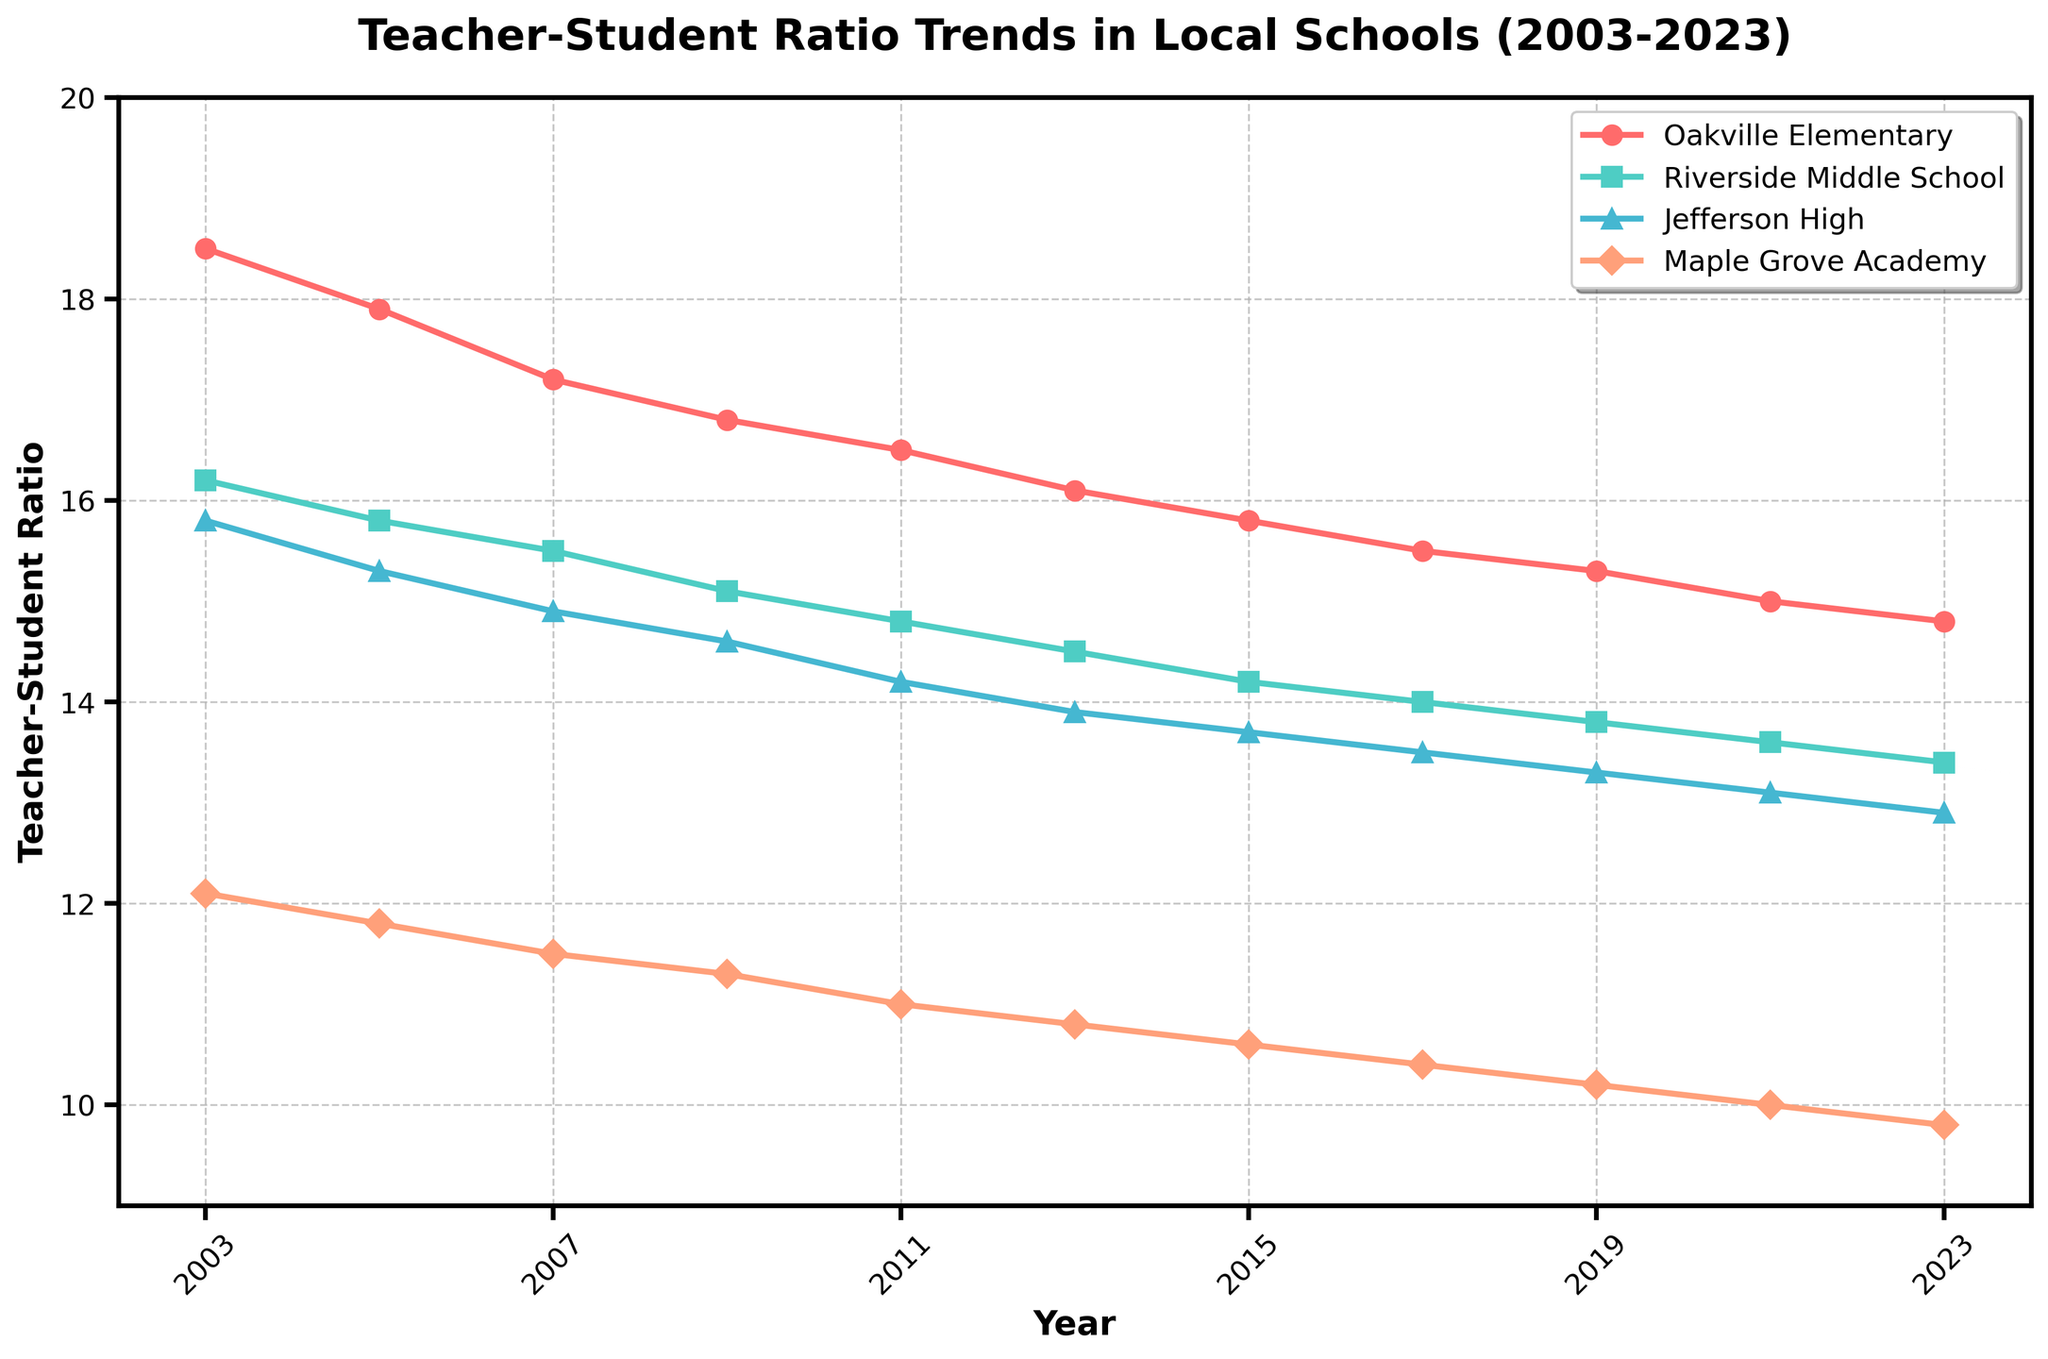What year had the lowest teacher-student ratio for Oakville Elementary? The y-axis shows the teacher-student ratio, and the x-axis the years. The lowest point on the line for Oakville Elementary indicates the lowest ratio. It occurs in 2023.
Answer: 2023 Which school had the highest teacher-student ratio in 2003? Check the line marks for each school in 2003. Compare their values, the highest is Oakville Elementary at 18.5.
Answer: Oakville Elementary By how much did the teacher-student ratio for Jefferson High decrease from 2003 to 2023? Calculate the difference between Jefferson High's ratios in 2003 and 2023: 15.8 - 12.9 = 2.9.
Answer: 2.9 How do the teacher-student ratios for Maple Grove Academy in 2013 and 2019 compare? Compare the heights of the markers for those years. In 2013, the ratio is 10.8 and in 2019, it's 10.2; 2013 is higher.
Answer: 2013 is higher What's the average teacher-student ratio at Riverside Middle School over the entire period? Sum the ratios from all years and divide by the number of years. (16.2 + 15.8 + 15.5 + 15.1 + 14.8 + 14.5 + 14.2 + 14.0 + 13.8 + 13.6 + 13.4) / 11 = 14.69.
Answer: 14.69 Which school had the most significant decrease in teacher-student ratio from 2003 to 2023? Calculate the decreases for all schools: Oakville Elementary (18.5 to 14.8), Riverside Middle School (16.2 to 13.4), Jefferson High (15.8 to 12.9), Maple Grove Academy (12.1 to 9.8). Oakville Elementary's decrease is largest at 3.7.
Answer: Oakville Elementary What is the median teacher-student ratio of Maple Grove Academy from 2003 to 2023? List the ratios in ascending order and find the middle value: [9.8, 10.0, 10.2, 10.4, 10.6, 10.8, 11.0, 11.3, 11.5, 11.8, 12.1]. The median value (6th position) is 10.8.
Answer: 10.8 In 2021, how did the teacher-student ratio of Riverside Middle School compare to all other schools? Compare the 2021 ratios: Oakville Elementary (15.0), Riverside Middle School (13.6), Jefferson High (13.1), Maple Grove Academy (10.0). Riverside is second lowest.
Answer: Second lowest By what percentage did the teacher-student ratio at Oakville Elementary decrease from 2003 to 2023? Calculate the percentage decrease: (18.5 - 14.8) / 18.5 * 100 = 20.0%.
Answer: 20.0% Which school had the most stable teacher-student ratio over the years? Look for the school line with the least fluctuation. Maple Grove Academy's line shows the smallest slope from 12.1 to 9.8, indicating stability.
Answer: Maple Grove Academy 